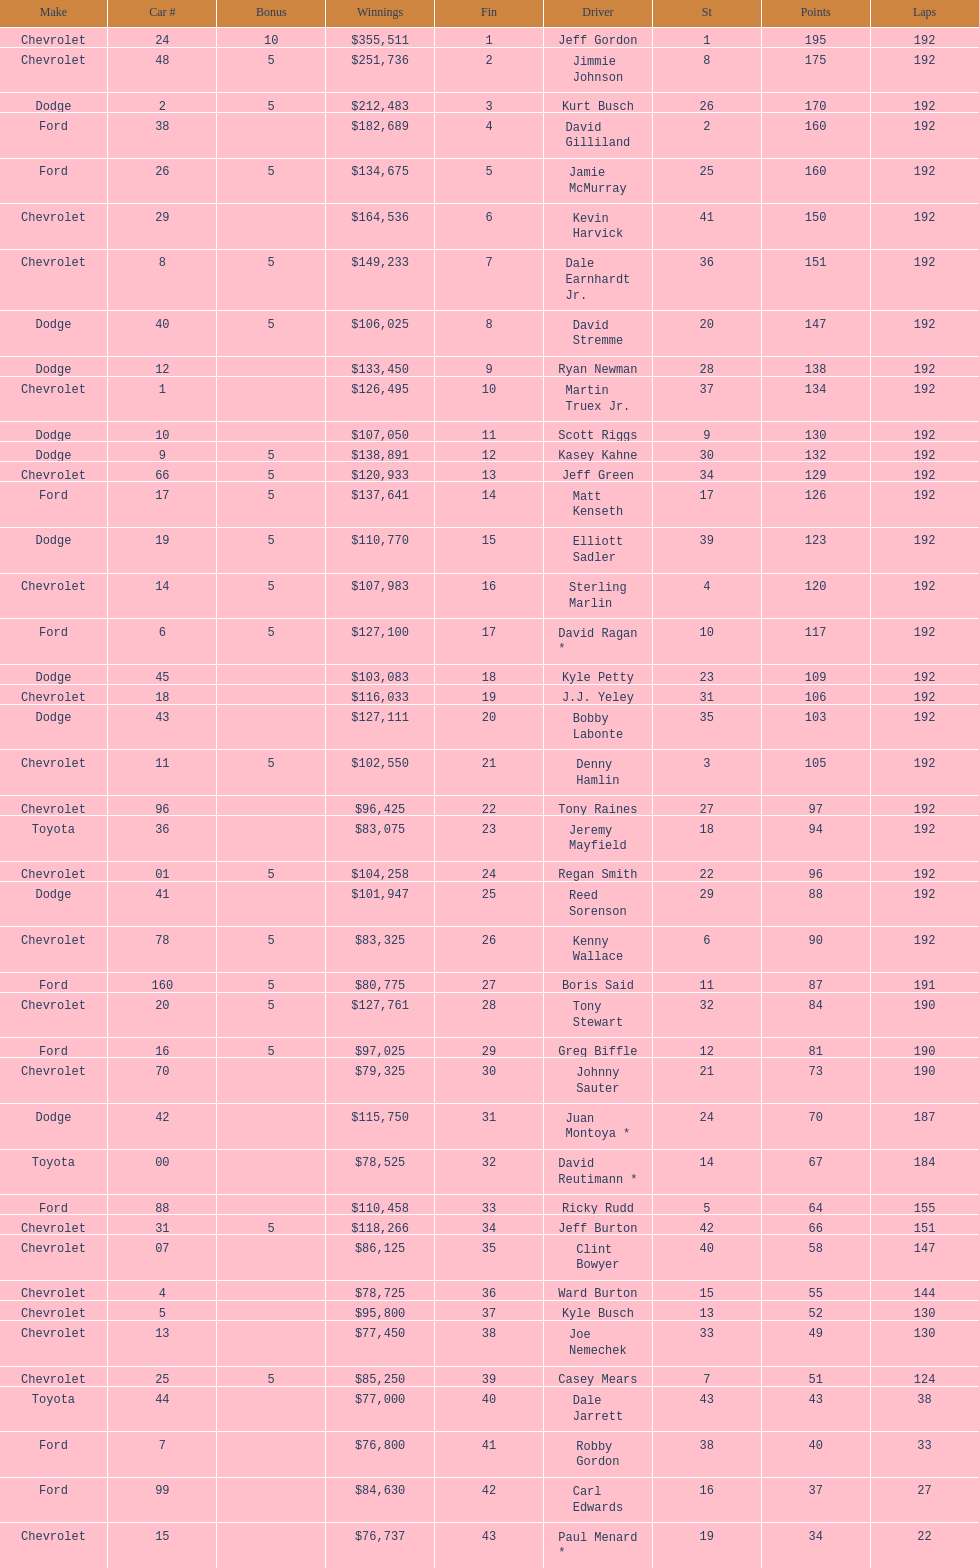How many drivers earned no bonus for this race? 23. 